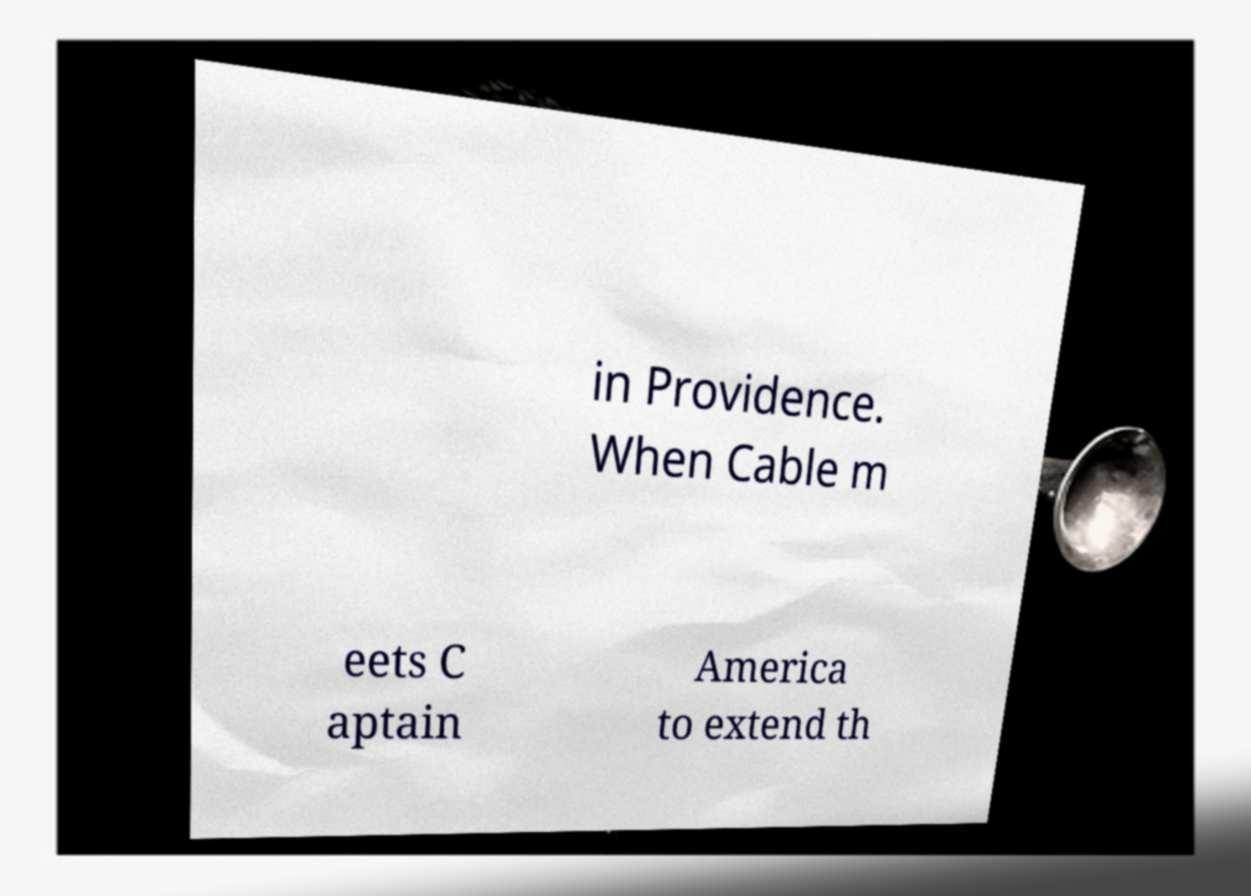For documentation purposes, I need the text within this image transcribed. Could you provide that? in Providence. When Cable m eets C aptain America to extend th 